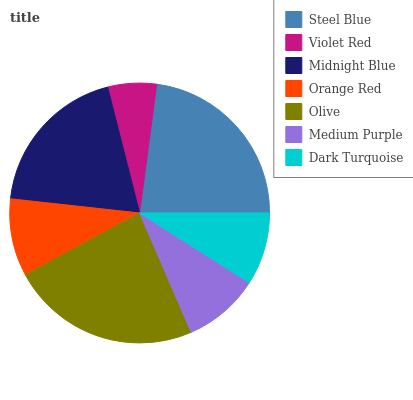Is Violet Red the minimum?
Answer yes or no. Yes. Is Olive the maximum?
Answer yes or no. Yes. Is Midnight Blue the minimum?
Answer yes or no. No. Is Midnight Blue the maximum?
Answer yes or no. No. Is Midnight Blue greater than Violet Red?
Answer yes or no. Yes. Is Violet Red less than Midnight Blue?
Answer yes or no. Yes. Is Violet Red greater than Midnight Blue?
Answer yes or no. No. Is Midnight Blue less than Violet Red?
Answer yes or no. No. Is Orange Red the high median?
Answer yes or no. Yes. Is Orange Red the low median?
Answer yes or no. Yes. Is Dark Turquoise the high median?
Answer yes or no. No. Is Violet Red the low median?
Answer yes or no. No. 